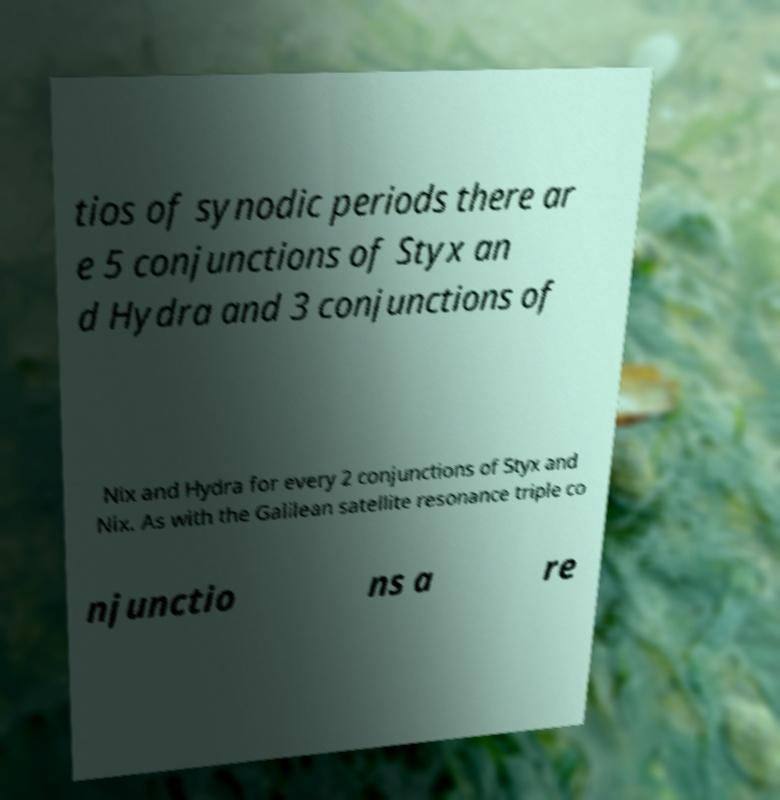For documentation purposes, I need the text within this image transcribed. Could you provide that? tios of synodic periods there ar e 5 conjunctions of Styx an d Hydra and 3 conjunctions of Nix and Hydra for every 2 conjunctions of Styx and Nix. As with the Galilean satellite resonance triple co njunctio ns a re 